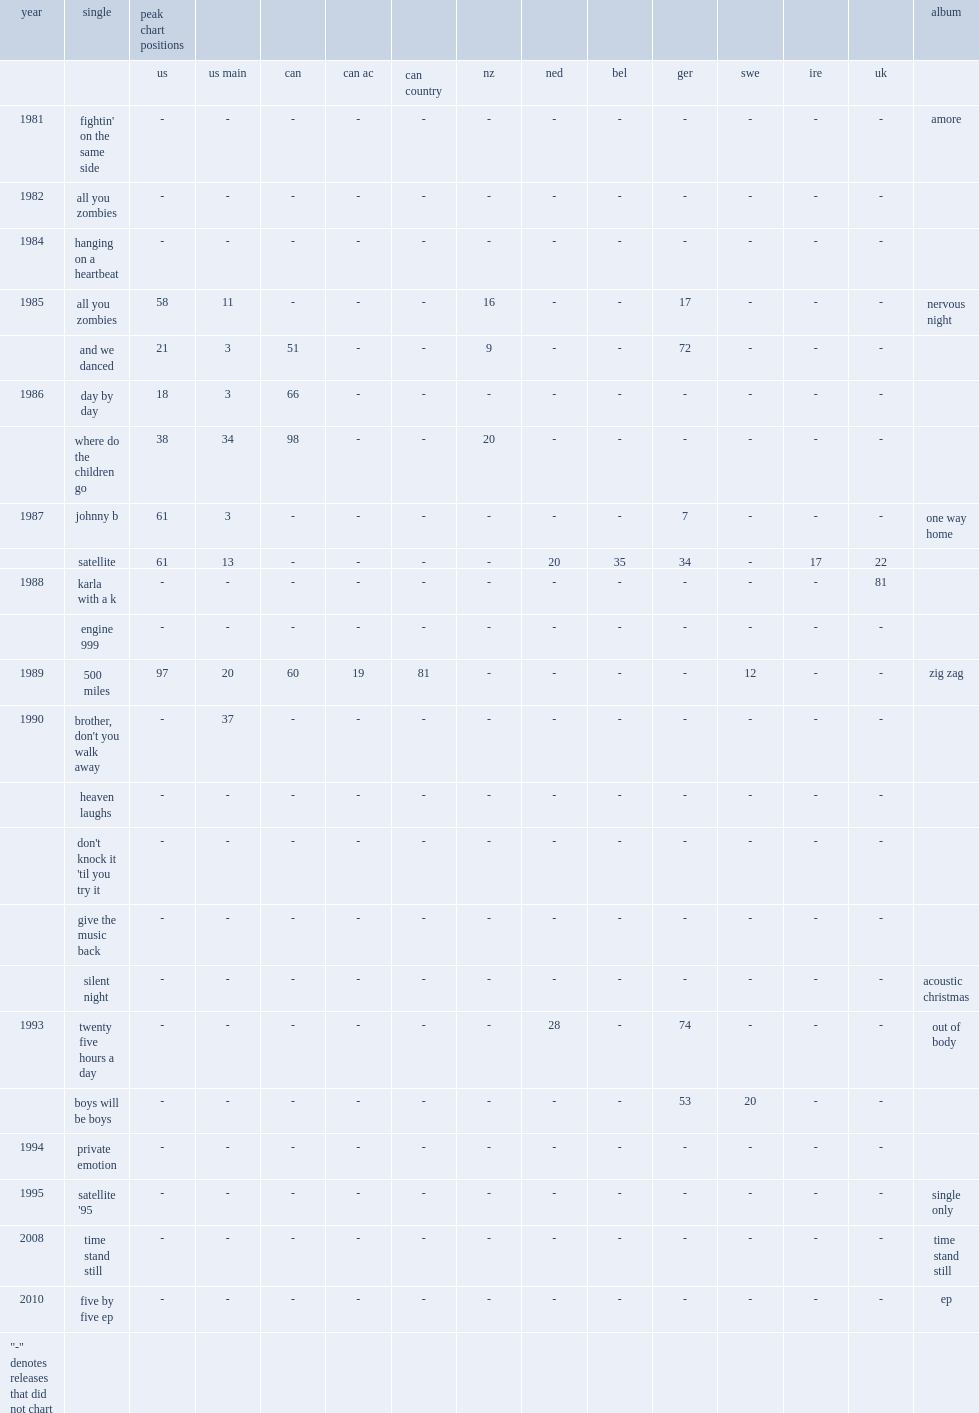In 1986, which album was "where do the children go" released from? Nervous night. 